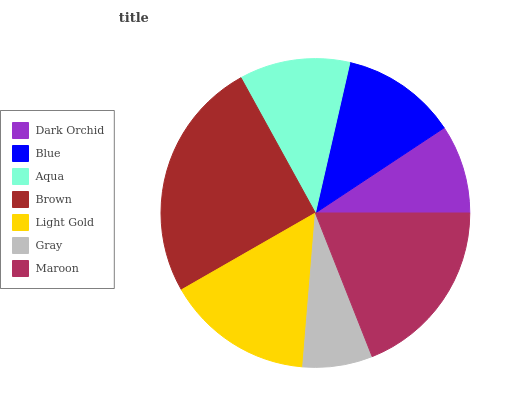Is Gray the minimum?
Answer yes or no. Yes. Is Brown the maximum?
Answer yes or no. Yes. Is Blue the minimum?
Answer yes or no. No. Is Blue the maximum?
Answer yes or no. No. Is Blue greater than Dark Orchid?
Answer yes or no. Yes. Is Dark Orchid less than Blue?
Answer yes or no. Yes. Is Dark Orchid greater than Blue?
Answer yes or no. No. Is Blue less than Dark Orchid?
Answer yes or no. No. Is Blue the high median?
Answer yes or no. Yes. Is Blue the low median?
Answer yes or no. Yes. Is Light Gold the high median?
Answer yes or no. No. Is Dark Orchid the low median?
Answer yes or no. No. 